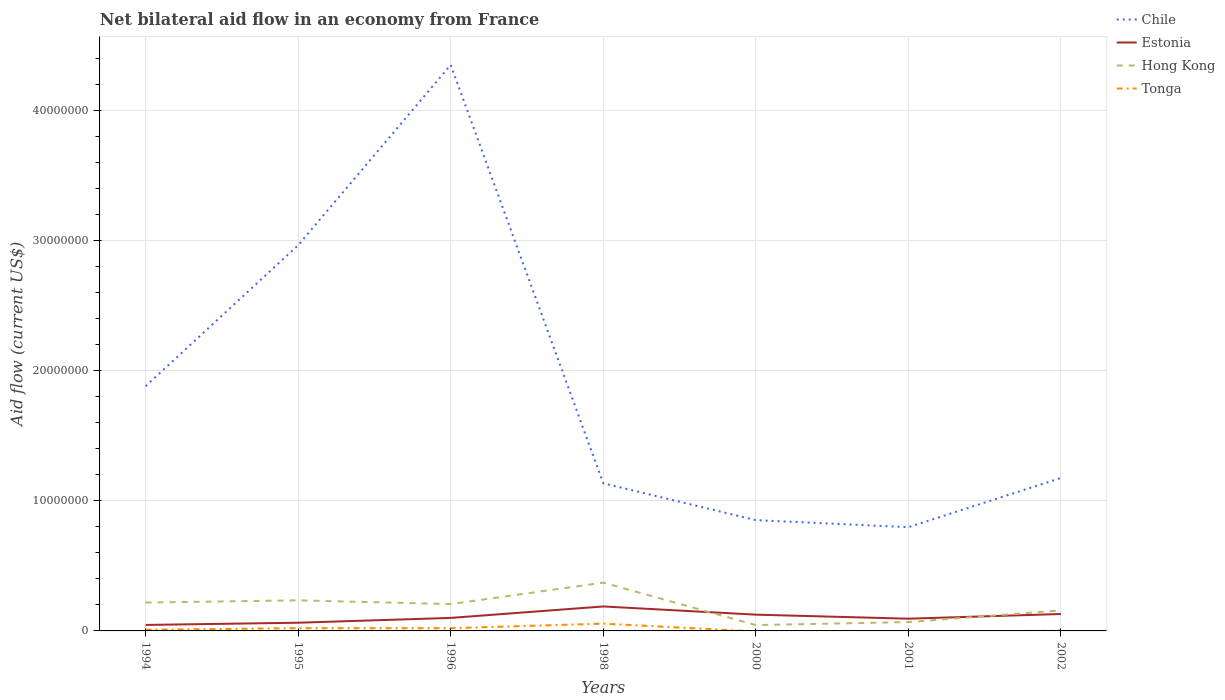How many different coloured lines are there?
Give a very brief answer. 4. Does the line corresponding to Hong Kong intersect with the line corresponding to Tonga?
Provide a succinct answer. No. Is the number of lines equal to the number of legend labels?
Your answer should be compact. No. Across all years, what is the maximum net bilateral aid flow in Chile?
Your response must be concise. 7.97e+06. What is the total net bilateral aid flow in Chile in the graph?
Ensure brevity in your answer.  2.11e+07. What is the difference between the highest and the second highest net bilateral aid flow in Estonia?
Keep it short and to the point. 1.42e+06. What is the difference between the highest and the lowest net bilateral aid flow in Chile?
Give a very brief answer. 3. What is the difference between two consecutive major ticks on the Y-axis?
Your response must be concise. 1.00e+07. Are the values on the major ticks of Y-axis written in scientific E-notation?
Keep it short and to the point. No. Does the graph contain any zero values?
Ensure brevity in your answer.  Yes. What is the title of the graph?
Your answer should be compact. Net bilateral aid flow in an economy from France. Does "High income: nonOECD" appear as one of the legend labels in the graph?
Make the answer very short. No. What is the label or title of the X-axis?
Make the answer very short. Years. What is the label or title of the Y-axis?
Your answer should be compact. Aid flow (current US$). What is the Aid flow (current US$) of Chile in 1994?
Provide a succinct answer. 1.88e+07. What is the Aid flow (current US$) in Hong Kong in 1994?
Offer a terse response. 2.18e+06. What is the Aid flow (current US$) of Chile in 1995?
Your response must be concise. 2.96e+07. What is the Aid flow (current US$) in Estonia in 1995?
Your answer should be very brief. 6.30e+05. What is the Aid flow (current US$) in Hong Kong in 1995?
Your response must be concise. 2.35e+06. What is the Aid flow (current US$) in Tonga in 1995?
Offer a very short reply. 2.10e+05. What is the Aid flow (current US$) in Chile in 1996?
Offer a very short reply. 4.35e+07. What is the Aid flow (current US$) in Hong Kong in 1996?
Your response must be concise. 2.06e+06. What is the Aid flow (current US$) in Tonga in 1996?
Offer a terse response. 2.10e+05. What is the Aid flow (current US$) in Chile in 1998?
Keep it short and to the point. 1.13e+07. What is the Aid flow (current US$) of Estonia in 1998?
Your response must be concise. 1.88e+06. What is the Aid flow (current US$) of Hong Kong in 1998?
Your answer should be very brief. 3.71e+06. What is the Aid flow (current US$) of Tonga in 1998?
Keep it short and to the point. 5.60e+05. What is the Aid flow (current US$) of Chile in 2000?
Your answer should be very brief. 8.51e+06. What is the Aid flow (current US$) of Estonia in 2000?
Keep it short and to the point. 1.25e+06. What is the Aid flow (current US$) in Hong Kong in 2000?
Offer a very short reply. 4.50e+05. What is the Aid flow (current US$) of Chile in 2001?
Keep it short and to the point. 7.97e+06. What is the Aid flow (current US$) in Estonia in 2001?
Provide a succinct answer. 9.40e+05. What is the Aid flow (current US$) of Hong Kong in 2001?
Your answer should be compact. 6.80e+05. What is the Aid flow (current US$) of Chile in 2002?
Offer a very short reply. 1.18e+07. What is the Aid flow (current US$) in Estonia in 2002?
Give a very brief answer. 1.30e+06. What is the Aid flow (current US$) of Hong Kong in 2002?
Your answer should be very brief. 1.58e+06. Across all years, what is the maximum Aid flow (current US$) in Chile?
Keep it short and to the point. 4.35e+07. Across all years, what is the maximum Aid flow (current US$) in Estonia?
Offer a terse response. 1.88e+06. Across all years, what is the maximum Aid flow (current US$) in Hong Kong?
Keep it short and to the point. 3.71e+06. Across all years, what is the maximum Aid flow (current US$) of Tonga?
Make the answer very short. 5.60e+05. Across all years, what is the minimum Aid flow (current US$) of Chile?
Make the answer very short. 7.97e+06. Across all years, what is the minimum Aid flow (current US$) in Tonga?
Your response must be concise. 0. What is the total Aid flow (current US$) in Chile in the graph?
Provide a succinct answer. 1.31e+08. What is the total Aid flow (current US$) in Estonia in the graph?
Keep it short and to the point. 7.46e+06. What is the total Aid flow (current US$) in Hong Kong in the graph?
Provide a short and direct response. 1.30e+07. What is the total Aid flow (current US$) in Tonga in the graph?
Your response must be concise. 1.09e+06. What is the difference between the Aid flow (current US$) of Chile in 1994 and that in 1995?
Provide a succinct answer. -1.08e+07. What is the difference between the Aid flow (current US$) in Tonga in 1994 and that in 1995?
Keep it short and to the point. -1.20e+05. What is the difference between the Aid flow (current US$) in Chile in 1994 and that in 1996?
Your response must be concise. -2.47e+07. What is the difference between the Aid flow (current US$) in Estonia in 1994 and that in 1996?
Offer a terse response. -5.40e+05. What is the difference between the Aid flow (current US$) of Chile in 1994 and that in 1998?
Keep it short and to the point. 7.46e+06. What is the difference between the Aid flow (current US$) in Estonia in 1994 and that in 1998?
Keep it short and to the point. -1.42e+06. What is the difference between the Aid flow (current US$) of Hong Kong in 1994 and that in 1998?
Your response must be concise. -1.53e+06. What is the difference between the Aid flow (current US$) in Tonga in 1994 and that in 1998?
Give a very brief answer. -4.70e+05. What is the difference between the Aid flow (current US$) of Chile in 1994 and that in 2000?
Your answer should be compact. 1.03e+07. What is the difference between the Aid flow (current US$) in Estonia in 1994 and that in 2000?
Keep it short and to the point. -7.90e+05. What is the difference between the Aid flow (current US$) of Hong Kong in 1994 and that in 2000?
Your answer should be compact. 1.73e+06. What is the difference between the Aid flow (current US$) in Chile in 1994 and that in 2001?
Ensure brevity in your answer.  1.08e+07. What is the difference between the Aid flow (current US$) of Estonia in 1994 and that in 2001?
Your response must be concise. -4.80e+05. What is the difference between the Aid flow (current US$) of Hong Kong in 1994 and that in 2001?
Give a very brief answer. 1.50e+06. What is the difference between the Aid flow (current US$) in Chile in 1994 and that in 2002?
Offer a terse response. 7.05e+06. What is the difference between the Aid flow (current US$) in Estonia in 1994 and that in 2002?
Your answer should be very brief. -8.40e+05. What is the difference between the Aid flow (current US$) in Tonga in 1994 and that in 2002?
Keep it short and to the point. 7.00e+04. What is the difference between the Aid flow (current US$) in Chile in 1995 and that in 1996?
Offer a terse response. -1.38e+07. What is the difference between the Aid flow (current US$) in Estonia in 1995 and that in 1996?
Make the answer very short. -3.70e+05. What is the difference between the Aid flow (current US$) in Hong Kong in 1995 and that in 1996?
Offer a terse response. 2.90e+05. What is the difference between the Aid flow (current US$) in Chile in 1995 and that in 1998?
Your answer should be very brief. 1.83e+07. What is the difference between the Aid flow (current US$) of Estonia in 1995 and that in 1998?
Ensure brevity in your answer.  -1.25e+06. What is the difference between the Aid flow (current US$) of Hong Kong in 1995 and that in 1998?
Give a very brief answer. -1.36e+06. What is the difference between the Aid flow (current US$) in Tonga in 1995 and that in 1998?
Ensure brevity in your answer.  -3.50e+05. What is the difference between the Aid flow (current US$) in Chile in 1995 and that in 2000?
Offer a terse response. 2.11e+07. What is the difference between the Aid flow (current US$) of Estonia in 1995 and that in 2000?
Provide a short and direct response. -6.20e+05. What is the difference between the Aid flow (current US$) of Hong Kong in 1995 and that in 2000?
Ensure brevity in your answer.  1.90e+06. What is the difference between the Aid flow (current US$) in Chile in 1995 and that in 2001?
Offer a very short reply. 2.17e+07. What is the difference between the Aid flow (current US$) in Estonia in 1995 and that in 2001?
Offer a very short reply. -3.10e+05. What is the difference between the Aid flow (current US$) in Hong Kong in 1995 and that in 2001?
Offer a very short reply. 1.67e+06. What is the difference between the Aid flow (current US$) in Chile in 1995 and that in 2002?
Offer a very short reply. 1.79e+07. What is the difference between the Aid flow (current US$) in Estonia in 1995 and that in 2002?
Provide a short and direct response. -6.70e+05. What is the difference between the Aid flow (current US$) in Hong Kong in 1995 and that in 2002?
Your answer should be very brief. 7.70e+05. What is the difference between the Aid flow (current US$) in Chile in 1996 and that in 1998?
Ensure brevity in your answer.  3.21e+07. What is the difference between the Aid flow (current US$) in Estonia in 1996 and that in 1998?
Your answer should be compact. -8.80e+05. What is the difference between the Aid flow (current US$) in Hong Kong in 1996 and that in 1998?
Offer a terse response. -1.65e+06. What is the difference between the Aid flow (current US$) in Tonga in 1996 and that in 1998?
Ensure brevity in your answer.  -3.50e+05. What is the difference between the Aid flow (current US$) of Chile in 1996 and that in 2000?
Provide a short and direct response. 3.50e+07. What is the difference between the Aid flow (current US$) of Hong Kong in 1996 and that in 2000?
Give a very brief answer. 1.61e+06. What is the difference between the Aid flow (current US$) of Chile in 1996 and that in 2001?
Your answer should be compact. 3.55e+07. What is the difference between the Aid flow (current US$) in Estonia in 1996 and that in 2001?
Your answer should be very brief. 6.00e+04. What is the difference between the Aid flow (current US$) of Hong Kong in 1996 and that in 2001?
Ensure brevity in your answer.  1.38e+06. What is the difference between the Aid flow (current US$) in Chile in 1996 and that in 2002?
Offer a very short reply. 3.17e+07. What is the difference between the Aid flow (current US$) of Chile in 1998 and that in 2000?
Provide a short and direct response. 2.83e+06. What is the difference between the Aid flow (current US$) of Estonia in 1998 and that in 2000?
Provide a succinct answer. 6.30e+05. What is the difference between the Aid flow (current US$) in Hong Kong in 1998 and that in 2000?
Offer a terse response. 3.26e+06. What is the difference between the Aid flow (current US$) of Chile in 1998 and that in 2001?
Offer a terse response. 3.37e+06. What is the difference between the Aid flow (current US$) in Estonia in 1998 and that in 2001?
Keep it short and to the point. 9.40e+05. What is the difference between the Aid flow (current US$) in Hong Kong in 1998 and that in 2001?
Offer a terse response. 3.03e+06. What is the difference between the Aid flow (current US$) in Chile in 1998 and that in 2002?
Your response must be concise. -4.10e+05. What is the difference between the Aid flow (current US$) in Estonia in 1998 and that in 2002?
Your answer should be very brief. 5.80e+05. What is the difference between the Aid flow (current US$) of Hong Kong in 1998 and that in 2002?
Ensure brevity in your answer.  2.13e+06. What is the difference between the Aid flow (current US$) of Tonga in 1998 and that in 2002?
Your response must be concise. 5.40e+05. What is the difference between the Aid flow (current US$) of Chile in 2000 and that in 2001?
Offer a terse response. 5.40e+05. What is the difference between the Aid flow (current US$) of Hong Kong in 2000 and that in 2001?
Your response must be concise. -2.30e+05. What is the difference between the Aid flow (current US$) in Chile in 2000 and that in 2002?
Offer a terse response. -3.24e+06. What is the difference between the Aid flow (current US$) in Hong Kong in 2000 and that in 2002?
Give a very brief answer. -1.13e+06. What is the difference between the Aid flow (current US$) in Chile in 2001 and that in 2002?
Make the answer very short. -3.78e+06. What is the difference between the Aid flow (current US$) of Estonia in 2001 and that in 2002?
Your answer should be very brief. -3.60e+05. What is the difference between the Aid flow (current US$) in Hong Kong in 2001 and that in 2002?
Ensure brevity in your answer.  -9.00e+05. What is the difference between the Aid flow (current US$) of Chile in 1994 and the Aid flow (current US$) of Estonia in 1995?
Give a very brief answer. 1.82e+07. What is the difference between the Aid flow (current US$) in Chile in 1994 and the Aid flow (current US$) in Hong Kong in 1995?
Offer a very short reply. 1.64e+07. What is the difference between the Aid flow (current US$) of Chile in 1994 and the Aid flow (current US$) of Tonga in 1995?
Your answer should be compact. 1.86e+07. What is the difference between the Aid flow (current US$) of Estonia in 1994 and the Aid flow (current US$) of Hong Kong in 1995?
Ensure brevity in your answer.  -1.89e+06. What is the difference between the Aid flow (current US$) in Hong Kong in 1994 and the Aid flow (current US$) in Tonga in 1995?
Offer a terse response. 1.97e+06. What is the difference between the Aid flow (current US$) in Chile in 1994 and the Aid flow (current US$) in Estonia in 1996?
Offer a very short reply. 1.78e+07. What is the difference between the Aid flow (current US$) in Chile in 1994 and the Aid flow (current US$) in Hong Kong in 1996?
Your answer should be compact. 1.67e+07. What is the difference between the Aid flow (current US$) in Chile in 1994 and the Aid flow (current US$) in Tonga in 1996?
Your answer should be very brief. 1.86e+07. What is the difference between the Aid flow (current US$) of Estonia in 1994 and the Aid flow (current US$) of Hong Kong in 1996?
Ensure brevity in your answer.  -1.60e+06. What is the difference between the Aid flow (current US$) in Hong Kong in 1994 and the Aid flow (current US$) in Tonga in 1996?
Provide a short and direct response. 1.97e+06. What is the difference between the Aid flow (current US$) in Chile in 1994 and the Aid flow (current US$) in Estonia in 1998?
Provide a short and direct response. 1.69e+07. What is the difference between the Aid flow (current US$) of Chile in 1994 and the Aid flow (current US$) of Hong Kong in 1998?
Your answer should be compact. 1.51e+07. What is the difference between the Aid flow (current US$) of Chile in 1994 and the Aid flow (current US$) of Tonga in 1998?
Provide a succinct answer. 1.82e+07. What is the difference between the Aid flow (current US$) of Estonia in 1994 and the Aid flow (current US$) of Hong Kong in 1998?
Your answer should be compact. -3.25e+06. What is the difference between the Aid flow (current US$) in Estonia in 1994 and the Aid flow (current US$) in Tonga in 1998?
Offer a very short reply. -1.00e+05. What is the difference between the Aid flow (current US$) of Hong Kong in 1994 and the Aid flow (current US$) of Tonga in 1998?
Provide a short and direct response. 1.62e+06. What is the difference between the Aid flow (current US$) of Chile in 1994 and the Aid flow (current US$) of Estonia in 2000?
Your answer should be compact. 1.76e+07. What is the difference between the Aid flow (current US$) of Chile in 1994 and the Aid flow (current US$) of Hong Kong in 2000?
Your answer should be compact. 1.84e+07. What is the difference between the Aid flow (current US$) in Chile in 1994 and the Aid flow (current US$) in Estonia in 2001?
Make the answer very short. 1.79e+07. What is the difference between the Aid flow (current US$) of Chile in 1994 and the Aid flow (current US$) of Hong Kong in 2001?
Your answer should be compact. 1.81e+07. What is the difference between the Aid flow (current US$) in Chile in 1994 and the Aid flow (current US$) in Estonia in 2002?
Offer a terse response. 1.75e+07. What is the difference between the Aid flow (current US$) of Chile in 1994 and the Aid flow (current US$) of Hong Kong in 2002?
Offer a very short reply. 1.72e+07. What is the difference between the Aid flow (current US$) in Chile in 1994 and the Aid flow (current US$) in Tonga in 2002?
Make the answer very short. 1.88e+07. What is the difference between the Aid flow (current US$) in Estonia in 1994 and the Aid flow (current US$) in Hong Kong in 2002?
Make the answer very short. -1.12e+06. What is the difference between the Aid flow (current US$) of Hong Kong in 1994 and the Aid flow (current US$) of Tonga in 2002?
Offer a terse response. 2.16e+06. What is the difference between the Aid flow (current US$) in Chile in 1995 and the Aid flow (current US$) in Estonia in 1996?
Your answer should be compact. 2.86e+07. What is the difference between the Aid flow (current US$) in Chile in 1995 and the Aid flow (current US$) in Hong Kong in 1996?
Your response must be concise. 2.76e+07. What is the difference between the Aid flow (current US$) of Chile in 1995 and the Aid flow (current US$) of Tonga in 1996?
Keep it short and to the point. 2.94e+07. What is the difference between the Aid flow (current US$) in Estonia in 1995 and the Aid flow (current US$) in Hong Kong in 1996?
Provide a succinct answer. -1.43e+06. What is the difference between the Aid flow (current US$) in Estonia in 1995 and the Aid flow (current US$) in Tonga in 1996?
Keep it short and to the point. 4.20e+05. What is the difference between the Aid flow (current US$) of Hong Kong in 1995 and the Aid flow (current US$) of Tonga in 1996?
Your response must be concise. 2.14e+06. What is the difference between the Aid flow (current US$) in Chile in 1995 and the Aid flow (current US$) in Estonia in 1998?
Your answer should be compact. 2.78e+07. What is the difference between the Aid flow (current US$) of Chile in 1995 and the Aid flow (current US$) of Hong Kong in 1998?
Offer a terse response. 2.59e+07. What is the difference between the Aid flow (current US$) of Chile in 1995 and the Aid flow (current US$) of Tonga in 1998?
Keep it short and to the point. 2.91e+07. What is the difference between the Aid flow (current US$) in Estonia in 1995 and the Aid flow (current US$) in Hong Kong in 1998?
Offer a terse response. -3.08e+06. What is the difference between the Aid flow (current US$) of Hong Kong in 1995 and the Aid flow (current US$) of Tonga in 1998?
Your answer should be very brief. 1.79e+06. What is the difference between the Aid flow (current US$) in Chile in 1995 and the Aid flow (current US$) in Estonia in 2000?
Your answer should be compact. 2.84e+07. What is the difference between the Aid flow (current US$) in Chile in 1995 and the Aid flow (current US$) in Hong Kong in 2000?
Provide a succinct answer. 2.92e+07. What is the difference between the Aid flow (current US$) in Estonia in 1995 and the Aid flow (current US$) in Hong Kong in 2000?
Offer a terse response. 1.80e+05. What is the difference between the Aid flow (current US$) of Chile in 1995 and the Aid flow (current US$) of Estonia in 2001?
Provide a short and direct response. 2.87e+07. What is the difference between the Aid flow (current US$) in Chile in 1995 and the Aid flow (current US$) in Hong Kong in 2001?
Offer a terse response. 2.90e+07. What is the difference between the Aid flow (current US$) in Chile in 1995 and the Aid flow (current US$) in Estonia in 2002?
Provide a succinct answer. 2.83e+07. What is the difference between the Aid flow (current US$) in Chile in 1995 and the Aid flow (current US$) in Hong Kong in 2002?
Provide a succinct answer. 2.80e+07. What is the difference between the Aid flow (current US$) of Chile in 1995 and the Aid flow (current US$) of Tonga in 2002?
Your answer should be compact. 2.96e+07. What is the difference between the Aid flow (current US$) of Estonia in 1995 and the Aid flow (current US$) of Hong Kong in 2002?
Your answer should be very brief. -9.50e+05. What is the difference between the Aid flow (current US$) of Hong Kong in 1995 and the Aid flow (current US$) of Tonga in 2002?
Offer a terse response. 2.33e+06. What is the difference between the Aid flow (current US$) of Chile in 1996 and the Aid flow (current US$) of Estonia in 1998?
Make the answer very short. 4.16e+07. What is the difference between the Aid flow (current US$) of Chile in 1996 and the Aid flow (current US$) of Hong Kong in 1998?
Make the answer very short. 3.98e+07. What is the difference between the Aid flow (current US$) of Chile in 1996 and the Aid flow (current US$) of Tonga in 1998?
Provide a short and direct response. 4.29e+07. What is the difference between the Aid flow (current US$) of Estonia in 1996 and the Aid flow (current US$) of Hong Kong in 1998?
Offer a very short reply. -2.71e+06. What is the difference between the Aid flow (current US$) of Estonia in 1996 and the Aid flow (current US$) of Tonga in 1998?
Offer a very short reply. 4.40e+05. What is the difference between the Aid flow (current US$) in Hong Kong in 1996 and the Aid flow (current US$) in Tonga in 1998?
Your response must be concise. 1.50e+06. What is the difference between the Aid flow (current US$) of Chile in 1996 and the Aid flow (current US$) of Estonia in 2000?
Make the answer very short. 4.22e+07. What is the difference between the Aid flow (current US$) in Chile in 1996 and the Aid flow (current US$) in Hong Kong in 2000?
Provide a succinct answer. 4.30e+07. What is the difference between the Aid flow (current US$) of Chile in 1996 and the Aid flow (current US$) of Estonia in 2001?
Your answer should be very brief. 4.25e+07. What is the difference between the Aid flow (current US$) in Chile in 1996 and the Aid flow (current US$) in Hong Kong in 2001?
Offer a terse response. 4.28e+07. What is the difference between the Aid flow (current US$) in Chile in 1996 and the Aid flow (current US$) in Estonia in 2002?
Keep it short and to the point. 4.22e+07. What is the difference between the Aid flow (current US$) in Chile in 1996 and the Aid flow (current US$) in Hong Kong in 2002?
Make the answer very short. 4.19e+07. What is the difference between the Aid flow (current US$) of Chile in 1996 and the Aid flow (current US$) of Tonga in 2002?
Offer a very short reply. 4.35e+07. What is the difference between the Aid flow (current US$) in Estonia in 1996 and the Aid flow (current US$) in Hong Kong in 2002?
Ensure brevity in your answer.  -5.80e+05. What is the difference between the Aid flow (current US$) of Estonia in 1996 and the Aid flow (current US$) of Tonga in 2002?
Your answer should be compact. 9.80e+05. What is the difference between the Aid flow (current US$) of Hong Kong in 1996 and the Aid flow (current US$) of Tonga in 2002?
Your answer should be very brief. 2.04e+06. What is the difference between the Aid flow (current US$) of Chile in 1998 and the Aid flow (current US$) of Estonia in 2000?
Offer a very short reply. 1.01e+07. What is the difference between the Aid flow (current US$) in Chile in 1998 and the Aid flow (current US$) in Hong Kong in 2000?
Your response must be concise. 1.09e+07. What is the difference between the Aid flow (current US$) in Estonia in 1998 and the Aid flow (current US$) in Hong Kong in 2000?
Give a very brief answer. 1.43e+06. What is the difference between the Aid flow (current US$) of Chile in 1998 and the Aid flow (current US$) of Estonia in 2001?
Your answer should be compact. 1.04e+07. What is the difference between the Aid flow (current US$) of Chile in 1998 and the Aid flow (current US$) of Hong Kong in 2001?
Give a very brief answer. 1.07e+07. What is the difference between the Aid flow (current US$) of Estonia in 1998 and the Aid flow (current US$) of Hong Kong in 2001?
Provide a short and direct response. 1.20e+06. What is the difference between the Aid flow (current US$) of Chile in 1998 and the Aid flow (current US$) of Estonia in 2002?
Ensure brevity in your answer.  1.00e+07. What is the difference between the Aid flow (current US$) of Chile in 1998 and the Aid flow (current US$) of Hong Kong in 2002?
Give a very brief answer. 9.76e+06. What is the difference between the Aid flow (current US$) of Chile in 1998 and the Aid flow (current US$) of Tonga in 2002?
Your answer should be compact. 1.13e+07. What is the difference between the Aid flow (current US$) in Estonia in 1998 and the Aid flow (current US$) in Hong Kong in 2002?
Provide a short and direct response. 3.00e+05. What is the difference between the Aid flow (current US$) in Estonia in 1998 and the Aid flow (current US$) in Tonga in 2002?
Ensure brevity in your answer.  1.86e+06. What is the difference between the Aid flow (current US$) of Hong Kong in 1998 and the Aid flow (current US$) of Tonga in 2002?
Make the answer very short. 3.69e+06. What is the difference between the Aid flow (current US$) of Chile in 2000 and the Aid flow (current US$) of Estonia in 2001?
Make the answer very short. 7.57e+06. What is the difference between the Aid flow (current US$) in Chile in 2000 and the Aid flow (current US$) in Hong Kong in 2001?
Offer a very short reply. 7.83e+06. What is the difference between the Aid flow (current US$) of Estonia in 2000 and the Aid flow (current US$) of Hong Kong in 2001?
Give a very brief answer. 5.70e+05. What is the difference between the Aid flow (current US$) in Chile in 2000 and the Aid flow (current US$) in Estonia in 2002?
Your response must be concise. 7.21e+06. What is the difference between the Aid flow (current US$) in Chile in 2000 and the Aid flow (current US$) in Hong Kong in 2002?
Ensure brevity in your answer.  6.93e+06. What is the difference between the Aid flow (current US$) of Chile in 2000 and the Aid flow (current US$) of Tonga in 2002?
Provide a short and direct response. 8.49e+06. What is the difference between the Aid flow (current US$) of Estonia in 2000 and the Aid flow (current US$) of Hong Kong in 2002?
Make the answer very short. -3.30e+05. What is the difference between the Aid flow (current US$) of Estonia in 2000 and the Aid flow (current US$) of Tonga in 2002?
Your answer should be compact. 1.23e+06. What is the difference between the Aid flow (current US$) in Chile in 2001 and the Aid flow (current US$) in Estonia in 2002?
Your answer should be very brief. 6.67e+06. What is the difference between the Aid flow (current US$) of Chile in 2001 and the Aid flow (current US$) of Hong Kong in 2002?
Provide a succinct answer. 6.39e+06. What is the difference between the Aid flow (current US$) of Chile in 2001 and the Aid flow (current US$) of Tonga in 2002?
Ensure brevity in your answer.  7.95e+06. What is the difference between the Aid flow (current US$) in Estonia in 2001 and the Aid flow (current US$) in Hong Kong in 2002?
Make the answer very short. -6.40e+05. What is the difference between the Aid flow (current US$) of Estonia in 2001 and the Aid flow (current US$) of Tonga in 2002?
Offer a terse response. 9.20e+05. What is the average Aid flow (current US$) of Chile per year?
Provide a succinct answer. 1.88e+07. What is the average Aid flow (current US$) in Estonia per year?
Offer a very short reply. 1.07e+06. What is the average Aid flow (current US$) in Hong Kong per year?
Keep it short and to the point. 1.86e+06. What is the average Aid flow (current US$) in Tonga per year?
Provide a short and direct response. 1.56e+05. In the year 1994, what is the difference between the Aid flow (current US$) of Chile and Aid flow (current US$) of Estonia?
Keep it short and to the point. 1.83e+07. In the year 1994, what is the difference between the Aid flow (current US$) of Chile and Aid flow (current US$) of Hong Kong?
Provide a succinct answer. 1.66e+07. In the year 1994, what is the difference between the Aid flow (current US$) in Chile and Aid flow (current US$) in Tonga?
Offer a very short reply. 1.87e+07. In the year 1994, what is the difference between the Aid flow (current US$) in Estonia and Aid flow (current US$) in Hong Kong?
Your answer should be very brief. -1.72e+06. In the year 1994, what is the difference between the Aid flow (current US$) in Hong Kong and Aid flow (current US$) in Tonga?
Your answer should be compact. 2.09e+06. In the year 1995, what is the difference between the Aid flow (current US$) in Chile and Aid flow (current US$) in Estonia?
Offer a terse response. 2.90e+07. In the year 1995, what is the difference between the Aid flow (current US$) in Chile and Aid flow (current US$) in Hong Kong?
Give a very brief answer. 2.73e+07. In the year 1995, what is the difference between the Aid flow (current US$) of Chile and Aid flow (current US$) of Tonga?
Provide a succinct answer. 2.94e+07. In the year 1995, what is the difference between the Aid flow (current US$) in Estonia and Aid flow (current US$) in Hong Kong?
Keep it short and to the point. -1.72e+06. In the year 1995, what is the difference between the Aid flow (current US$) in Estonia and Aid flow (current US$) in Tonga?
Offer a very short reply. 4.20e+05. In the year 1995, what is the difference between the Aid flow (current US$) of Hong Kong and Aid flow (current US$) of Tonga?
Ensure brevity in your answer.  2.14e+06. In the year 1996, what is the difference between the Aid flow (current US$) of Chile and Aid flow (current US$) of Estonia?
Your response must be concise. 4.25e+07. In the year 1996, what is the difference between the Aid flow (current US$) in Chile and Aid flow (current US$) in Hong Kong?
Offer a very short reply. 4.14e+07. In the year 1996, what is the difference between the Aid flow (current US$) in Chile and Aid flow (current US$) in Tonga?
Your answer should be very brief. 4.33e+07. In the year 1996, what is the difference between the Aid flow (current US$) in Estonia and Aid flow (current US$) in Hong Kong?
Your response must be concise. -1.06e+06. In the year 1996, what is the difference between the Aid flow (current US$) of Estonia and Aid flow (current US$) of Tonga?
Offer a very short reply. 7.90e+05. In the year 1996, what is the difference between the Aid flow (current US$) of Hong Kong and Aid flow (current US$) of Tonga?
Your response must be concise. 1.85e+06. In the year 1998, what is the difference between the Aid flow (current US$) of Chile and Aid flow (current US$) of Estonia?
Your answer should be very brief. 9.46e+06. In the year 1998, what is the difference between the Aid flow (current US$) in Chile and Aid flow (current US$) in Hong Kong?
Provide a succinct answer. 7.63e+06. In the year 1998, what is the difference between the Aid flow (current US$) of Chile and Aid flow (current US$) of Tonga?
Offer a very short reply. 1.08e+07. In the year 1998, what is the difference between the Aid flow (current US$) in Estonia and Aid flow (current US$) in Hong Kong?
Your answer should be very brief. -1.83e+06. In the year 1998, what is the difference between the Aid flow (current US$) in Estonia and Aid flow (current US$) in Tonga?
Keep it short and to the point. 1.32e+06. In the year 1998, what is the difference between the Aid flow (current US$) of Hong Kong and Aid flow (current US$) of Tonga?
Offer a terse response. 3.15e+06. In the year 2000, what is the difference between the Aid flow (current US$) of Chile and Aid flow (current US$) of Estonia?
Give a very brief answer. 7.26e+06. In the year 2000, what is the difference between the Aid flow (current US$) in Chile and Aid flow (current US$) in Hong Kong?
Your answer should be very brief. 8.06e+06. In the year 2000, what is the difference between the Aid flow (current US$) of Estonia and Aid flow (current US$) of Hong Kong?
Offer a very short reply. 8.00e+05. In the year 2001, what is the difference between the Aid flow (current US$) in Chile and Aid flow (current US$) in Estonia?
Make the answer very short. 7.03e+06. In the year 2001, what is the difference between the Aid flow (current US$) in Chile and Aid flow (current US$) in Hong Kong?
Keep it short and to the point. 7.29e+06. In the year 2002, what is the difference between the Aid flow (current US$) of Chile and Aid flow (current US$) of Estonia?
Keep it short and to the point. 1.04e+07. In the year 2002, what is the difference between the Aid flow (current US$) in Chile and Aid flow (current US$) in Hong Kong?
Offer a very short reply. 1.02e+07. In the year 2002, what is the difference between the Aid flow (current US$) of Chile and Aid flow (current US$) of Tonga?
Provide a succinct answer. 1.17e+07. In the year 2002, what is the difference between the Aid flow (current US$) of Estonia and Aid flow (current US$) of Hong Kong?
Provide a short and direct response. -2.80e+05. In the year 2002, what is the difference between the Aid flow (current US$) of Estonia and Aid flow (current US$) of Tonga?
Provide a short and direct response. 1.28e+06. In the year 2002, what is the difference between the Aid flow (current US$) of Hong Kong and Aid flow (current US$) of Tonga?
Keep it short and to the point. 1.56e+06. What is the ratio of the Aid flow (current US$) of Chile in 1994 to that in 1995?
Provide a succinct answer. 0.63. What is the ratio of the Aid flow (current US$) of Estonia in 1994 to that in 1995?
Your response must be concise. 0.73. What is the ratio of the Aid flow (current US$) of Hong Kong in 1994 to that in 1995?
Your answer should be very brief. 0.93. What is the ratio of the Aid flow (current US$) in Tonga in 1994 to that in 1995?
Provide a short and direct response. 0.43. What is the ratio of the Aid flow (current US$) in Chile in 1994 to that in 1996?
Your answer should be compact. 0.43. What is the ratio of the Aid flow (current US$) of Estonia in 1994 to that in 1996?
Your answer should be very brief. 0.46. What is the ratio of the Aid flow (current US$) in Hong Kong in 1994 to that in 1996?
Ensure brevity in your answer.  1.06. What is the ratio of the Aid flow (current US$) of Tonga in 1994 to that in 1996?
Provide a succinct answer. 0.43. What is the ratio of the Aid flow (current US$) of Chile in 1994 to that in 1998?
Your answer should be very brief. 1.66. What is the ratio of the Aid flow (current US$) of Estonia in 1994 to that in 1998?
Provide a short and direct response. 0.24. What is the ratio of the Aid flow (current US$) of Hong Kong in 1994 to that in 1998?
Your answer should be compact. 0.59. What is the ratio of the Aid flow (current US$) of Tonga in 1994 to that in 1998?
Provide a short and direct response. 0.16. What is the ratio of the Aid flow (current US$) of Chile in 1994 to that in 2000?
Make the answer very short. 2.21. What is the ratio of the Aid flow (current US$) in Estonia in 1994 to that in 2000?
Your answer should be very brief. 0.37. What is the ratio of the Aid flow (current US$) in Hong Kong in 1994 to that in 2000?
Your answer should be very brief. 4.84. What is the ratio of the Aid flow (current US$) of Chile in 1994 to that in 2001?
Offer a very short reply. 2.36. What is the ratio of the Aid flow (current US$) of Estonia in 1994 to that in 2001?
Offer a terse response. 0.49. What is the ratio of the Aid flow (current US$) in Hong Kong in 1994 to that in 2001?
Make the answer very short. 3.21. What is the ratio of the Aid flow (current US$) of Estonia in 1994 to that in 2002?
Offer a very short reply. 0.35. What is the ratio of the Aid flow (current US$) in Hong Kong in 1994 to that in 2002?
Make the answer very short. 1.38. What is the ratio of the Aid flow (current US$) in Chile in 1995 to that in 1996?
Keep it short and to the point. 0.68. What is the ratio of the Aid flow (current US$) in Estonia in 1995 to that in 1996?
Offer a terse response. 0.63. What is the ratio of the Aid flow (current US$) in Hong Kong in 1995 to that in 1996?
Your answer should be very brief. 1.14. What is the ratio of the Aid flow (current US$) in Chile in 1995 to that in 1998?
Your answer should be very brief. 2.61. What is the ratio of the Aid flow (current US$) of Estonia in 1995 to that in 1998?
Make the answer very short. 0.34. What is the ratio of the Aid flow (current US$) of Hong Kong in 1995 to that in 1998?
Give a very brief answer. 0.63. What is the ratio of the Aid flow (current US$) of Chile in 1995 to that in 2000?
Your response must be concise. 3.48. What is the ratio of the Aid flow (current US$) of Estonia in 1995 to that in 2000?
Ensure brevity in your answer.  0.5. What is the ratio of the Aid flow (current US$) of Hong Kong in 1995 to that in 2000?
Ensure brevity in your answer.  5.22. What is the ratio of the Aid flow (current US$) in Chile in 1995 to that in 2001?
Offer a terse response. 3.72. What is the ratio of the Aid flow (current US$) in Estonia in 1995 to that in 2001?
Your response must be concise. 0.67. What is the ratio of the Aid flow (current US$) of Hong Kong in 1995 to that in 2001?
Provide a short and direct response. 3.46. What is the ratio of the Aid flow (current US$) in Chile in 1995 to that in 2002?
Your answer should be compact. 2.52. What is the ratio of the Aid flow (current US$) of Estonia in 1995 to that in 2002?
Make the answer very short. 0.48. What is the ratio of the Aid flow (current US$) in Hong Kong in 1995 to that in 2002?
Your answer should be compact. 1.49. What is the ratio of the Aid flow (current US$) of Chile in 1996 to that in 1998?
Offer a terse response. 3.83. What is the ratio of the Aid flow (current US$) of Estonia in 1996 to that in 1998?
Keep it short and to the point. 0.53. What is the ratio of the Aid flow (current US$) in Hong Kong in 1996 to that in 1998?
Ensure brevity in your answer.  0.56. What is the ratio of the Aid flow (current US$) of Tonga in 1996 to that in 1998?
Keep it short and to the point. 0.38. What is the ratio of the Aid flow (current US$) in Chile in 1996 to that in 2000?
Offer a very short reply. 5.11. What is the ratio of the Aid flow (current US$) in Estonia in 1996 to that in 2000?
Provide a short and direct response. 0.8. What is the ratio of the Aid flow (current US$) of Hong Kong in 1996 to that in 2000?
Your answer should be compact. 4.58. What is the ratio of the Aid flow (current US$) in Chile in 1996 to that in 2001?
Keep it short and to the point. 5.46. What is the ratio of the Aid flow (current US$) in Estonia in 1996 to that in 2001?
Provide a succinct answer. 1.06. What is the ratio of the Aid flow (current US$) in Hong Kong in 1996 to that in 2001?
Your answer should be very brief. 3.03. What is the ratio of the Aid flow (current US$) of Chile in 1996 to that in 2002?
Give a very brief answer. 3.7. What is the ratio of the Aid flow (current US$) of Estonia in 1996 to that in 2002?
Offer a very short reply. 0.77. What is the ratio of the Aid flow (current US$) of Hong Kong in 1996 to that in 2002?
Ensure brevity in your answer.  1.3. What is the ratio of the Aid flow (current US$) in Chile in 1998 to that in 2000?
Give a very brief answer. 1.33. What is the ratio of the Aid flow (current US$) of Estonia in 1998 to that in 2000?
Ensure brevity in your answer.  1.5. What is the ratio of the Aid flow (current US$) of Hong Kong in 1998 to that in 2000?
Provide a short and direct response. 8.24. What is the ratio of the Aid flow (current US$) in Chile in 1998 to that in 2001?
Ensure brevity in your answer.  1.42. What is the ratio of the Aid flow (current US$) in Estonia in 1998 to that in 2001?
Make the answer very short. 2. What is the ratio of the Aid flow (current US$) in Hong Kong in 1998 to that in 2001?
Keep it short and to the point. 5.46. What is the ratio of the Aid flow (current US$) of Chile in 1998 to that in 2002?
Offer a terse response. 0.97. What is the ratio of the Aid flow (current US$) in Estonia in 1998 to that in 2002?
Ensure brevity in your answer.  1.45. What is the ratio of the Aid flow (current US$) in Hong Kong in 1998 to that in 2002?
Provide a short and direct response. 2.35. What is the ratio of the Aid flow (current US$) in Tonga in 1998 to that in 2002?
Ensure brevity in your answer.  28. What is the ratio of the Aid flow (current US$) of Chile in 2000 to that in 2001?
Provide a short and direct response. 1.07. What is the ratio of the Aid flow (current US$) of Estonia in 2000 to that in 2001?
Keep it short and to the point. 1.33. What is the ratio of the Aid flow (current US$) of Hong Kong in 2000 to that in 2001?
Give a very brief answer. 0.66. What is the ratio of the Aid flow (current US$) in Chile in 2000 to that in 2002?
Your response must be concise. 0.72. What is the ratio of the Aid flow (current US$) of Estonia in 2000 to that in 2002?
Make the answer very short. 0.96. What is the ratio of the Aid flow (current US$) of Hong Kong in 2000 to that in 2002?
Your answer should be very brief. 0.28. What is the ratio of the Aid flow (current US$) in Chile in 2001 to that in 2002?
Your response must be concise. 0.68. What is the ratio of the Aid flow (current US$) of Estonia in 2001 to that in 2002?
Your answer should be very brief. 0.72. What is the ratio of the Aid flow (current US$) of Hong Kong in 2001 to that in 2002?
Your answer should be very brief. 0.43. What is the difference between the highest and the second highest Aid flow (current US$) in Chile?
Provide a succinct answer. 1.38e+07. What is the difference between the highest and the second highest Aid flow (current US$) in Estonia?
Offer a terse response. 5.80e+05. What is the difference between the highest and the second highest Aid flow (current US$) in Hong Kong?
Offer a terse response. 1.36e+06. What is the difference between the highest and the second highest Aid flow (current US$) in Tonga?
Provide a short and direct response. 3.50e+05. What is the difference between the highest and the lowest Aid flow (current US$) in Chile?
Offer a terse response. 3.55e+07. What is the difference between the highest and the lowest Aid flow (current US$) of Estonia?
Make the answer very short. 1.42e+06. What is the difference between the highest and the lowest Aid flow (current US$) in Hong Kong?
Make the answer very short. 3.26e+06. What is the difference between the highest and the lowest Aid flow (current US$) in Tonga?
Provide a succinct answer. 5.60e+05. 